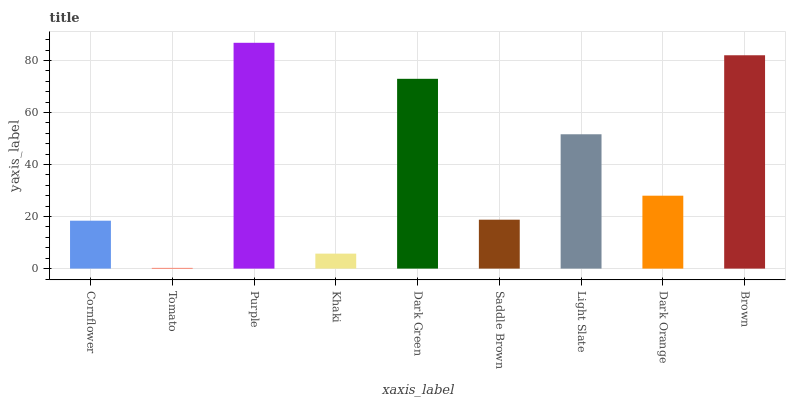Is Tomato the minimum?
Answer yes or no. Yes. Is Purple the maximum?
Answer yes or no. Yes. Is Purple the minimum?
Answer yes or no. No. Is Tomato the maximum?
Answer yes or no. No. Is Purple greater than Tomato?
Answer yes or no. Yes. Is Tomato less than Purple?
Answer yes or no. Yes. Is Tomato greater than Purple?
Answer yes or no. No. Is Purple less than Tomato?
Answer yes or no. No. Is Dark Orange the high median?
Answer yes or no. Yes. Is Dark Orange the low median?
Answer yes or no. Yes. Is Dark Green the high median?
Answer yes or no. No. Is Brown the low median?
Answer yes or no. No. 